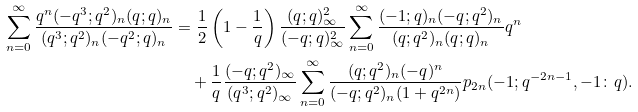Convert formula to latex. <formula><loc_0><loc_0><loc_500><loc_500>\sum _ { n = 0 } ^ { \infty } \frac { q ^ { n } ( - q ^ { 3 } ; q ^ { 2 } ) _ { n } ( q ; q ) _ { n } } { ( q ^ { 3 } ; q ^ { 2 } ) _ { n } ( - q ^ { 2 } ; q ) _ { n } } & = \frac { 1 } { 2 } \left ( 1 - \frac { 1 } { q } \right ) \frac { ( q ; q ) _ { \infty } ^ { 2 } } { ( - q ; q ) _ { \infty } ^ { 2 } } \sum _ { n = 0 } ^ { \infty } \frac { ( - 1 ; q ) _ { n } ( - q ; q ^ { 2 } ) _ { n } } { ( q ; q ^ { 2 } ) _ { n } ( q ; q ) _ { n } } q ^ { n } \\ & \quad + \frac { 1 } { q } \frac { ( - q ; q ^ { 2 } ) _ { \infty } } { ( q ^ { 3 } ; q ^ { 2 } ) _ { \infty } } \sum _ { n = 0 } ^ { \infty } \frac { ( q ; q ^ { 2 } ) _ { n } ( - q ) ^ { n } } { ( - q ; q ^ { 2 } ) _ { n } ( 1 + q ^ { 2 n } ) } p _ { 2 n } ( - 1 ; q ^ { - 2 n - 1 } , - 1 \colon q ) .</formula> 